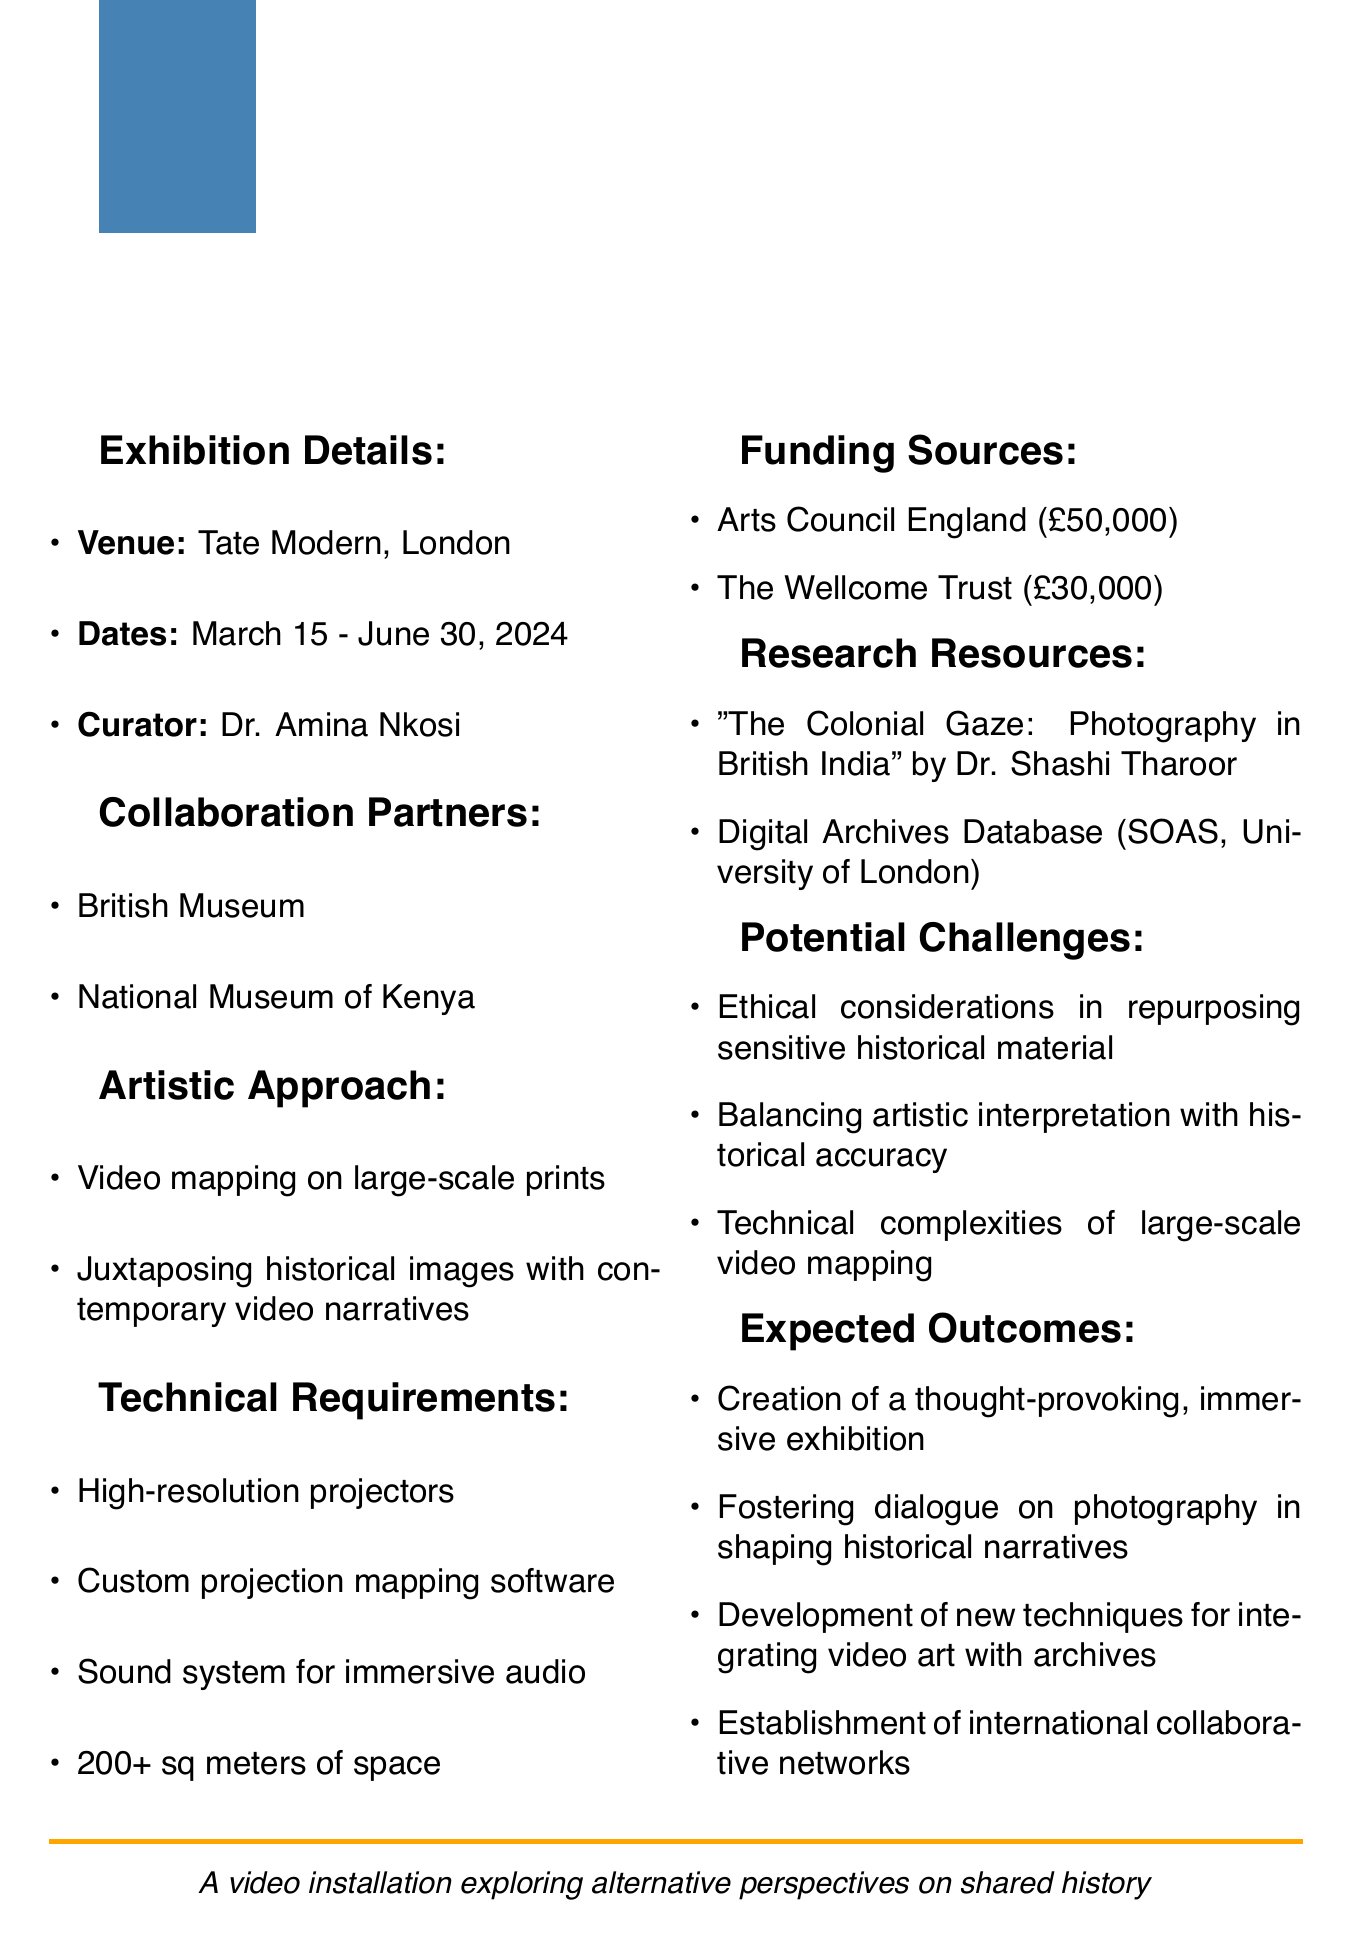What is the title of the exhibition? The title is clearly stated in the document as "Reframing the Past: Colonial Photographs Reimagined."
Answer: Reframing the Past: Colonial Photographs Reimagined Who is the curator of the exhibition? The document specifies that the curator is Dr. Amina Nkosi.
Answer: Dr. Amina Nkosi What are the exhibition dates? The dates for the exhibition are mentioned in the document as March 15 - June 30, 2024.
Answer: March 15 - June 30, 2024 What is one of the themes of the exhibition? The document lists themes, one of which is "Memory and collective history."
Answer: Memory and collective history How much funding is being sought from Arts Council England? The document indicates that a grant amount of £50,000 is being sought from Arts Council England.
Answer: £50,000 What is a potential challenge mentioned in the memo? The document outlines challenges, one of which is "Balancing artistic interpretation with historical accuracy."
Answer: Balancing artistic interpretation with historical accuracy What is the minimum space required for the exhibition? The document states that a minimum of 200 square meters of exhibition space is required.
Answer: Minimum 200 square meters Which museum is a collaboration partner? The document lists collaboration partners; one is the British Museum.
Answer: British Museum What is the purpose of the exhibition? The expected outcome listed is "Fostering dialogue on the role of photography in shaping historical narratives."
Answer: Fostering dialogue on the role of photography in shaping historical narratives 